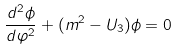<formula> <loc_0><loc_0><loc_500><loc_500>\frac { d ^ { 2 } \phi } { d \varphi ^ { 2 } } + ( m ^ { 2 } - U _ { 3 } ) \phi = 0</formula> 